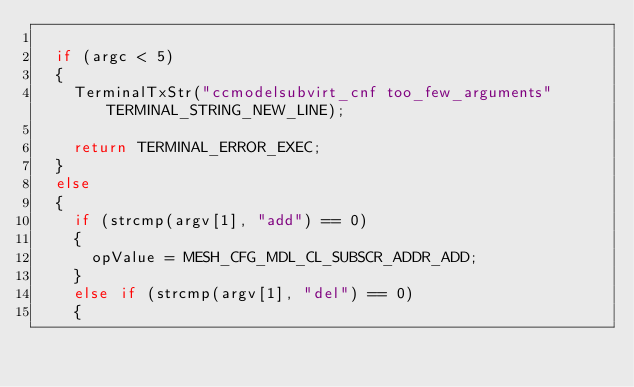<code> <loc_0><loc_0><loc_500><loc_500><_C_>
  if (argc < 5)
  {
    TerminalTxStr("ccmodelsubvirt_cnf too_few_arguments" TERMINAL_STRING_NEW_LINE);

    return TERMINAL_ERROR_EXEC;
  }
  else
  {
    if (strcmp(argv[1], "add") == 0)
    {
      opValue = MESH_CFG_MDL_CL_SUBSCR_ADDR_ADD;
    }
    else if (strcmp(argv[1], "del") == 0)
    {</code> 